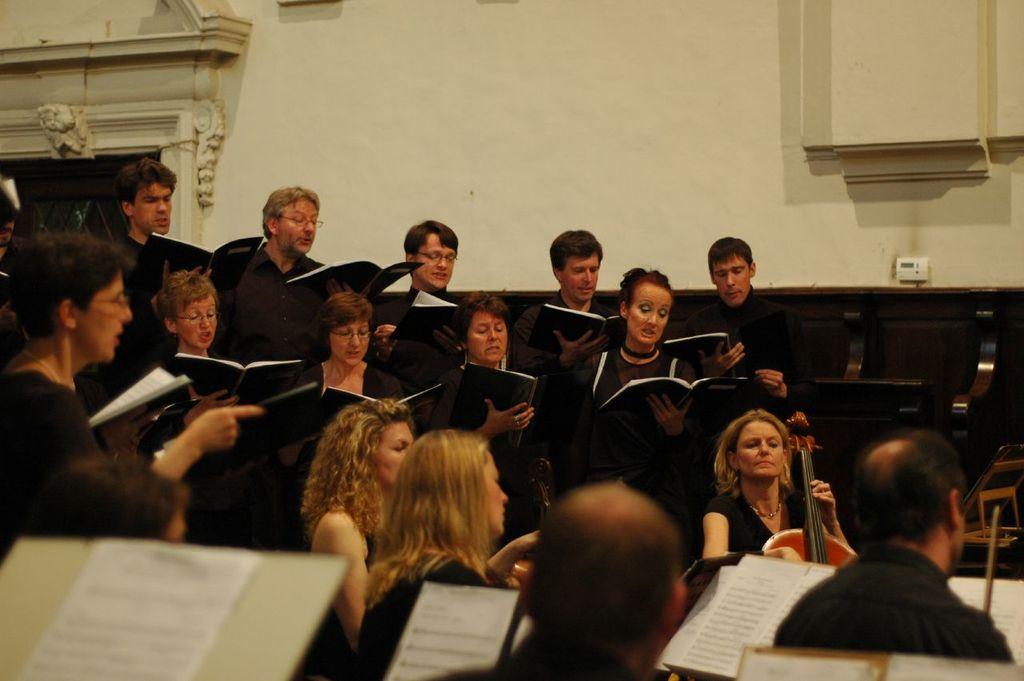In one or two sentences, can you explain what this image depicts? In this image we can see there are people standing and holding books and there are a few people sitting and the other person holding a musical instrument. And at the side, we can see the wall with a design and a wooden object. 